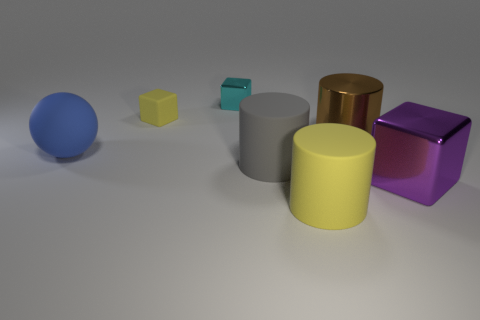Subtract all large matte cylinders. How many cylinders are left? 1 Add 2 big brown shiny things. How many objects exist? 9 Subtract all yellow cubes. How many cubes are left? 2 Subtract all blocks. How many objects are left? 4 Subtract all gray things. Subtract all spheres. How many objects are left? 5 Add 7 yellow blocks. How many yellow blocks are left? 8 Add 4 large purple blocks. How many large purple blocks exist? 5 Subtract 0 green blocks. How many objects are left? 7 Subtract all red cylinders. Subtract all yellow blocks. How many cylinders are left? 3 